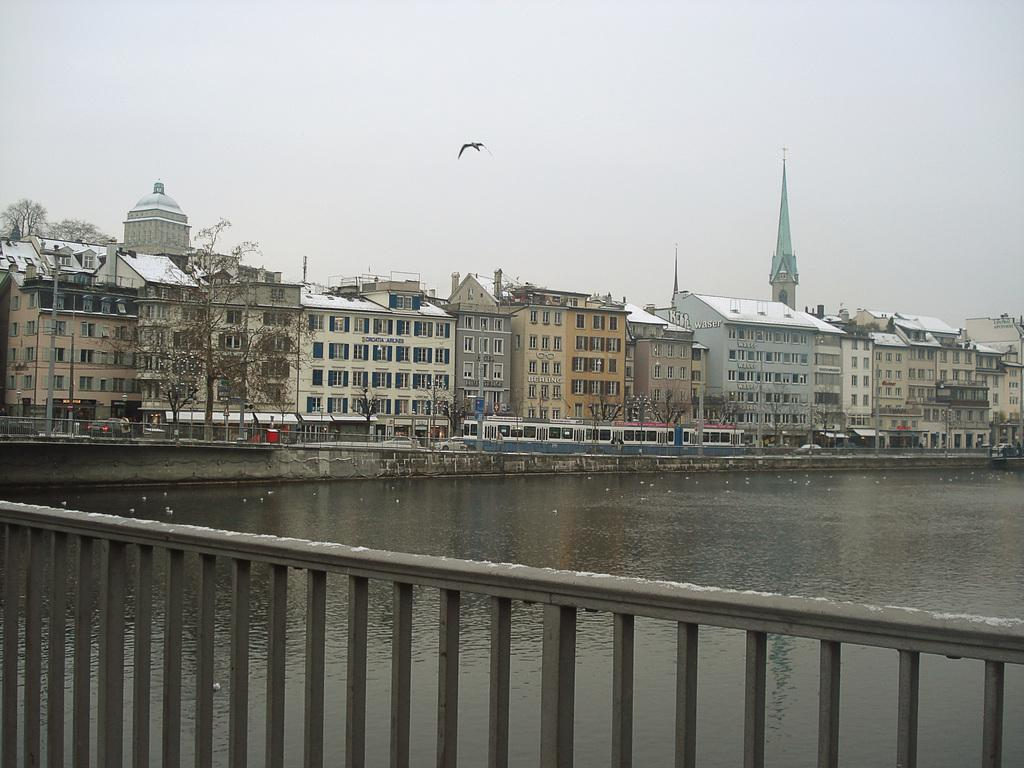What is the primary element visible in the image? There is water in the image. What type of structure can be seen in the image? There is fencing in the image. What type of man-made structures are present in the image? There are buildings in the image. What type of animal can be seen in the image? A bird is flying in the image. What part of the natural environment is visible in the image? The sky is visible at the top of the image. Can you tell me how many ministers are swimming in the water in the image? There are no ministers or swimming activities present in the image. 